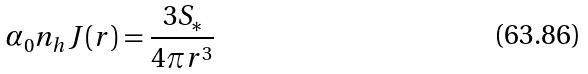<formula> <loc_0><loc_0><loc_500><loc_500>\alpha _ { 0 } n _ { h } J ( r ) = \frac { 3 S _ { * } } { 4 \pi r ^ { 3 } }</formula> 